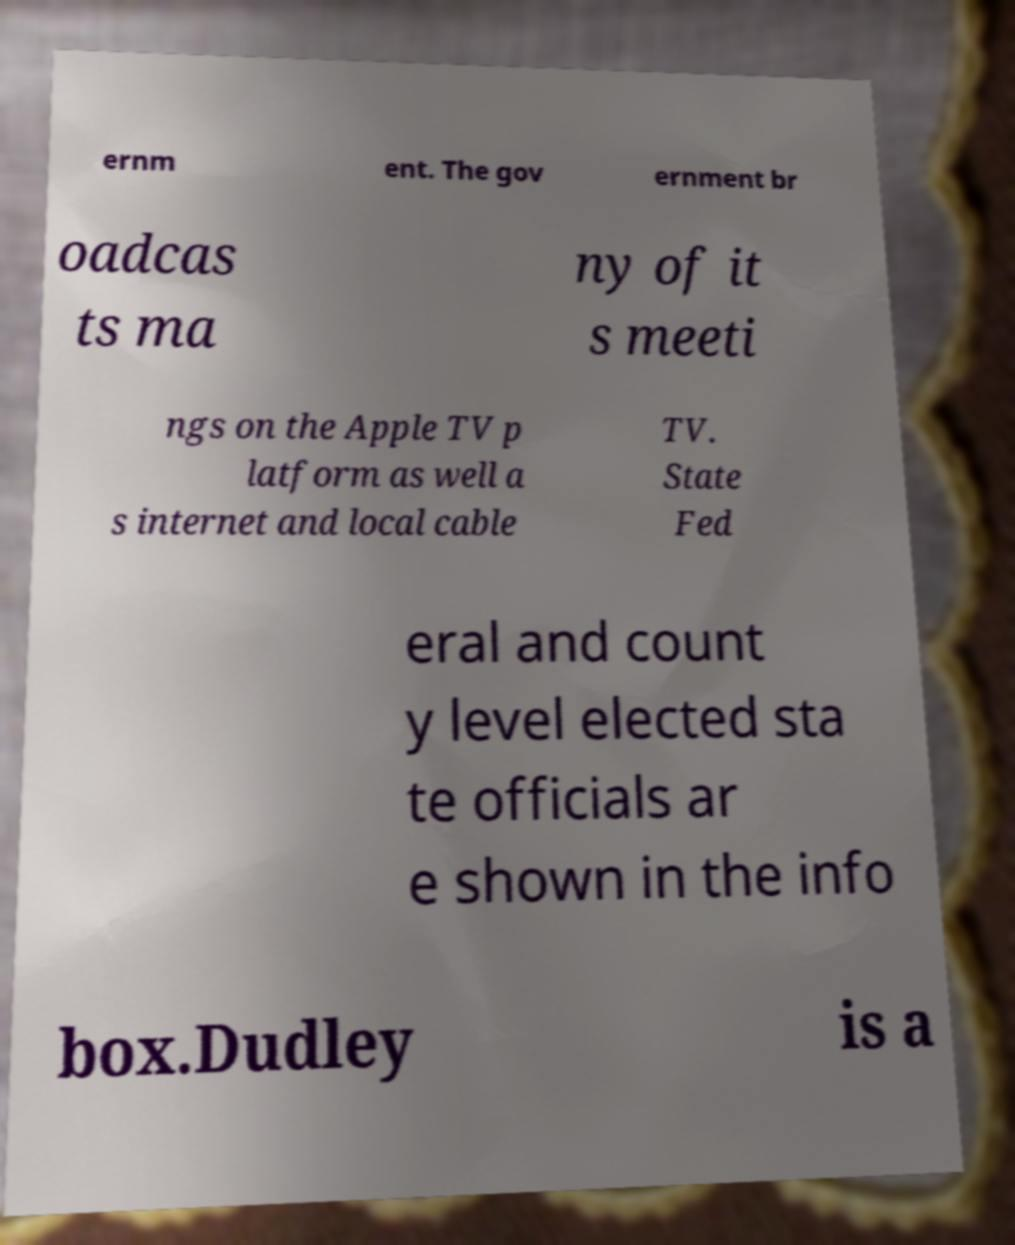Please identify and transcribe the text found in this image. ernm ent. The gov ernment br oadcas ts ma ny of it s meeti ngs on the Apple TV p latform as well a s internet and local cable TV. State Fed eral and count y level elected sta te officials ar e shown in the info box.Dudley is a 